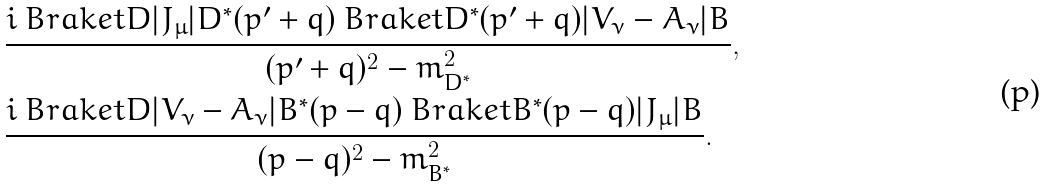Convert formula to latex. <formula><loc_0><loc_0><loc_500><loc_500>& \frac { i \ B r a k e t { D | J _ { \mu } | D ^ { * } ( p ^ { \prime } + q ) } \ B r a k e t { D ^ { * } ( p ^ { \prime } + q ) | V _ { \nu } - A _ { \nu } | B } } { ( p ^ { \prime } + q ) ^ { 2 } - m _ { D ^ { * } } ^ { 2 } } , \\ & \frac { i \ B r a k e t { D | V _ { \nu } - A _ { \nu } | B ^ { * } ( p - q ) } \ B r a k e t { B ^ { * } ( p - q ) | J _ { \mu } | B } } { ( p - q ) ^ { 2 } - m _ { B ^ { * } } ^ { 2 } } .</formula> 